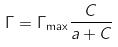Convert formula to latex. <formula><loc_0><loc_0><loc_500><loc_500>\Gamma = \Gamma _ { \max } \frac { C } { a + C }</formula> 